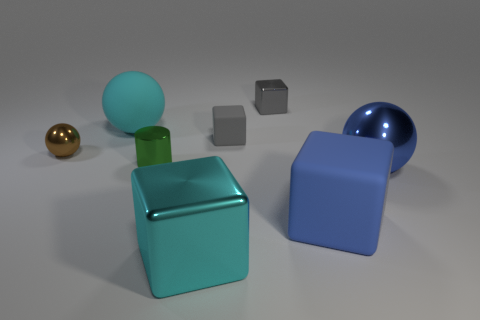Which objects in the scene could fit inside the blue hollow cube? The brown shiny object and the gray rubber block could likely fit inside the blue hollow cube given their relative sizes. 